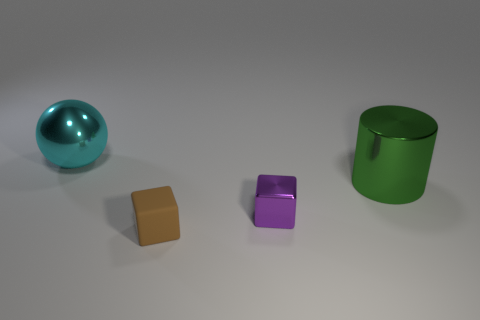What is the color of the object behind the big cylinder?
Offer a very short reply. Cyan. The big thing in front of the shiny object that is behind the big thing in front of the cyan metallic ball is made of what material?
Your answer should be very brief. Metal. Is there a large metallic object of the same shape as the small brown thing?
Offer a very short reply. No. There is a green object that is the same size as the cyan metal sphere; what is its shape?
Ensure brevity in your answer.  Cylinder. What number of objects are behind the small purple metal cube and to the right of the brown matte block?
Keep it short and to the point. 1. Are there fewer matte objects on the left side of the big cyan ball than green cylinders?
Keep it short and to the point. Yes. Is there a purple object of the same size as the metallic sphere?
Ensure brevity in your answer.  No. There is a small block that is made of the same material as the cyan object; what is its color?
Provide a succinct answer. Purple. What number of objects are right of the thing on the left side of the brown cube?
Your response must be concise. 3. What is the thing that is to the left of the green object and behind the purple metallic thing made of?
Provide a short and direct response. Metal. 